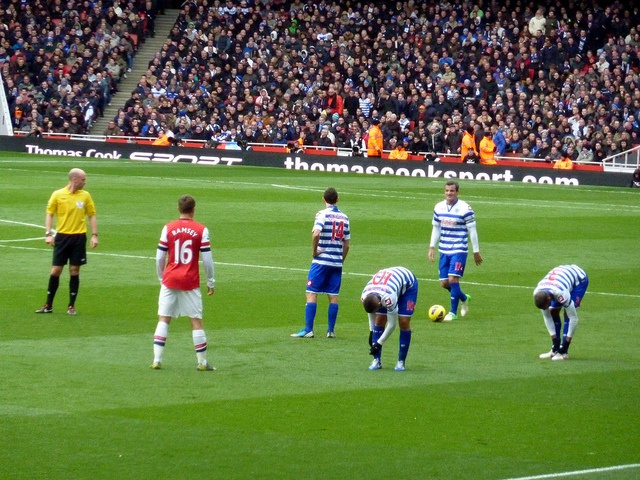Describe the objects in this image and their specific colors. I can see people in purple, black, gray, and darkgray tones, people in purple, lightgray, darkgray, brown, and olive tones, people in purple, navy, green, white, and darkblue tones, people in purple, black, gold, and olive tones, and people in purple, white, black, navy, and gray tones in this image. 